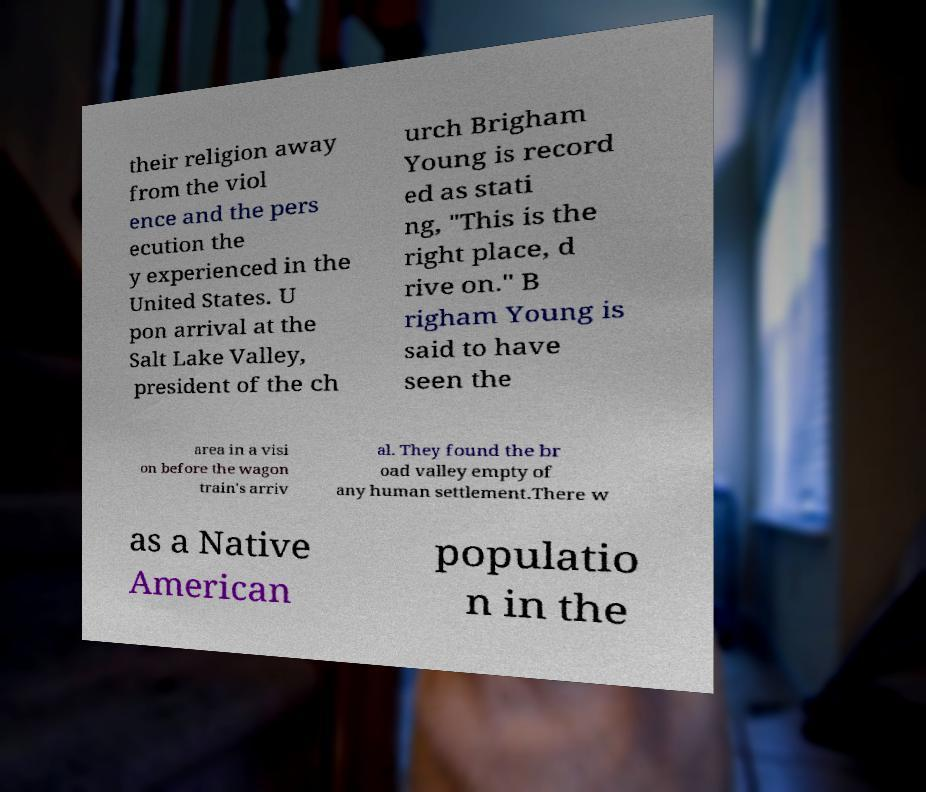Please identify and transcribe the text found in this image. their religion away from the viol ence and the pers ecution the y experienced in the United States. U pon arrival at the Salt Lake Valley, president of the ch urch Brigham Young is record ed as stati ng, "This is the right place, d rive on." B righam Young is said to have seen the area in a visi on before the wagon train's arriv al. They found the br oad valley empty of any human settlement.There w as a Native American populatio n in the 